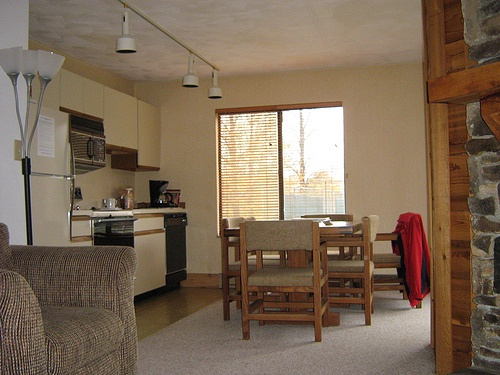Describe the objects in this image and their specific colors. I can see chair in gray and black tones, couch in gray and black tones, chair in gray, maroon, and black tones, refrigerator in gray, darkgray, and black tones, and chair in gray, maroon, black, and brown tones in this image. 